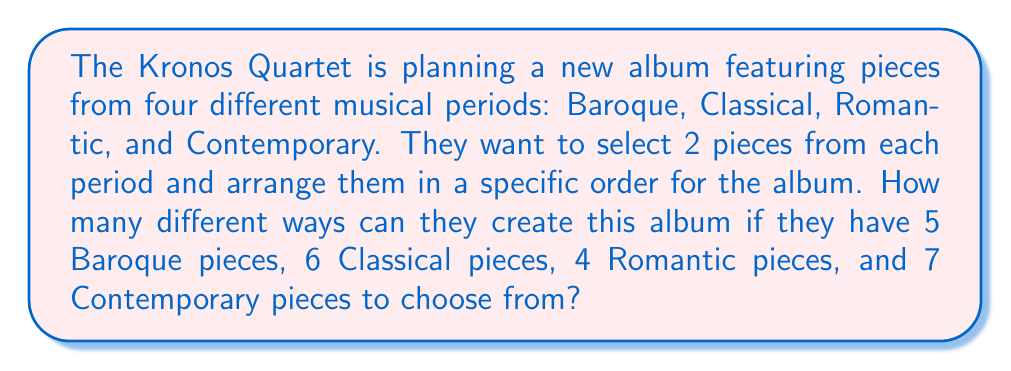What is the answer to this math problem? Let's break this down step-by-step:

1. First, we need to calculate the number of ways to select 2 pieces from each period:

   Baroque: $\binom{5}{2}$
   Classical: $\binom{6}{2}$
   Romantic: $\binom{4}{2}$
   Contemporary: $\binom{7}{2}$

2. Calculate each combination:
   
   Baroque: $\binom{5}{2} = \frac{5!}{2!(5-2)!} = \frac{5 \cdot 4}{2 \cdot 1} = 10$
   Classical: $\binom{6}{2} = \frac{6!}{2!(6-2)!} = \frac{6 \cdot 5}{2 \cdot 1} = 15$
   Romantic: $\binom{4}{2} = \frac{4!}{2!(4-2)!} = \frac{4 \cdot 3}{2 \cdot 1} = 6$
   Contemporary: $\binom{7}{2} = \frac{7!}{2!(7-2)!} = \frac{7 \cdot 6}{2 \cdot 1} = 21$

3. The total number of ways to select 2 pieces from each period is the product of these combinations:

   $10 \cdot 15 \cdot 6 \cdot 21 = 18,900$

4. Now, we need to consider the number of ways to arrange these 8 selected pieces (2 from each of the 4 periods) in order. This is a straightforward permutation of 8 items:

   $8! = 8 \cdot 7 \cdot 6 \cdot 5 \cdot 4 \cdot 3 \cdot 2 \cdot 1 = 40,320$

5. By the multiplication principle, the total number of ways to both select and arrange the pieces is:

   $18,900 \cdot 40,320 = 762,048,000$

Therefore, there are 762,048,000 different ways to create this album.
Answer: 762,048,000 